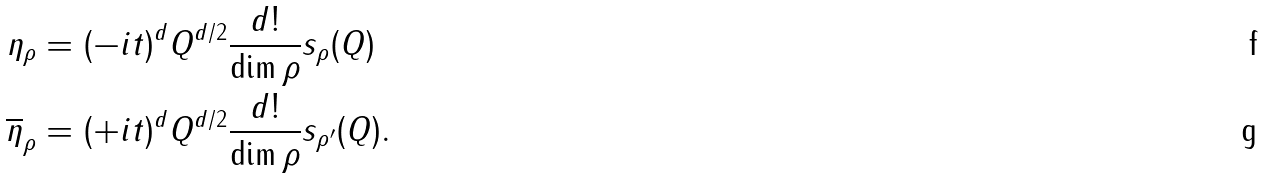Convert formula to latex. <formula><loc_0><loc_0><loc_500><loc_500>\eta _ { \rho } & = ( - i t ) ^ { d } Q ^ { d / 2 } \frac { d ! } { \dim \rho } s _ { \rho } ( Q ) \\ \overline { \eta } _ { \rho } & = ( + i t ) ^ { d } Q ^ { d / 2 } \frac { d ! } { \dim \rho } s _ { \rho ^ { \prime } } ( Q ) .</formula> 